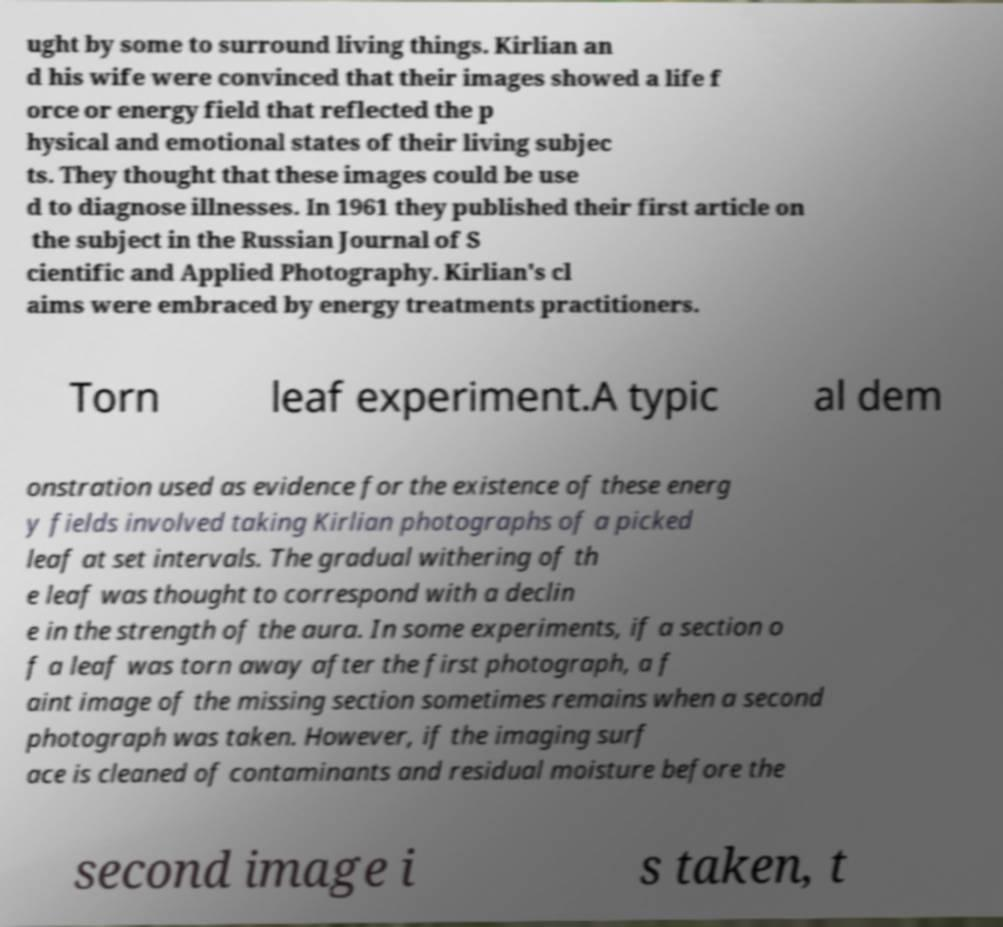There's text embedded in this image that I need extracted. Can you transcribe it verbatim? ught by some to surround living things. Kirlian an d his wife were convinced that their images showed a life f orce or energy field that reflected the p hysical and emotional states of their living subjec ts. They thought that these images could be use d to diagnose illnesses. In 1961 they published their first article on the subject in the Russian Journal of S cientific and Applied Photography. Kirlian's cl aims were embraced by energy treatments practitioners. Torn leaf experiment.A typic al dem onstration used as evidence for the existence of these energ y fields involved taking Kirlian photographs of a picked leaf at set intervals. The gradual withering of th e leaf was thought to correspond with a declin e in the strength of the aura. In some experiments, if a section o f a leaf was torn away after the first photograph, a f aint image of the missing section sometimes remains when a second photograph was taken. However, if the imaging surf ace is cleaned of contaminants and residual moisture before the second image i s taken, t 